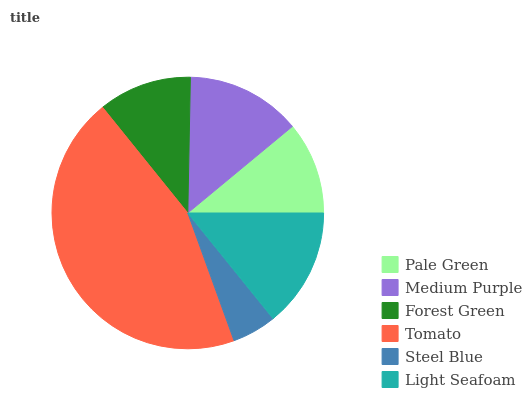Is Steel Blue the minimum?
Answer yes or no. Yes. Is Tomato the maximum?
Answer yes or no. Yes. Is Medium Purple the minimum?
Answer yes or no. No. Is Medium Purple the maximum?
Answer yes or no. No. Is Medium Purple greater than Pale Green?
Answer yes or no. Yes. Is Pale Green less than Medium Purple?
Answer yes or no. Yes. Is Pale Green greater than Medium Purple?
Answer yes or no. No. Is Medium Purple less than Pale Green?
Answer yes or no. No. Is Medium Purple the high median?
Answer yes or no. Yes. Is Forest Green the low median?
Answer yes or no. Yes. Is Light Seafoam the high median?
Answer yes or no. No. Is Medium Purple the low median?
Answer yes or no. No. 